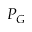<formula> <loc_0><loc_0><loc_500><loc_500>P _ { G }</formula> 